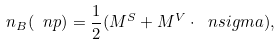Convert formula to latex. <formula><loc_0><loc_0><loc_500><loc_500>n _ { B } ( \ n p ) = \frac { 1 } { 2 } ( M ^ { S } + { M } ^ { V } \cdot \ n s i g m a ) ,</formula> 